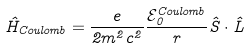Convert formula to latex. <formula><loc_0><loc_0><loc_500><loc_500>\hat { H } _ { C o u l o m b } = \frac { e } { 2 m ^ { 2 } c ^ { 2 } } \frac { \mathcal { E } _ { 0 } ^ { C o u l o m b } } { r } \hat { S } \cdot \hat { L }</formula> 